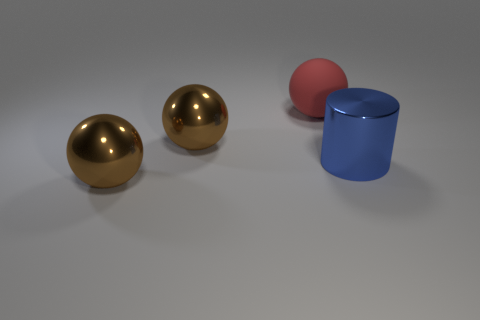Add 1 red matte balls. How many objects exist? 5 Subtract all spheres. How many objects are left? 1 Subtract 0 yellow spheres. How many objects are left? 4 Subtract all big rubber cylinders. Subtract all big blue things. How many objects are left? 3 Add 4 brown metal objects. How many brown metal objects are left? 6 Add 2 small cyan matte balls. How many small cyan matte balls exist? 2 